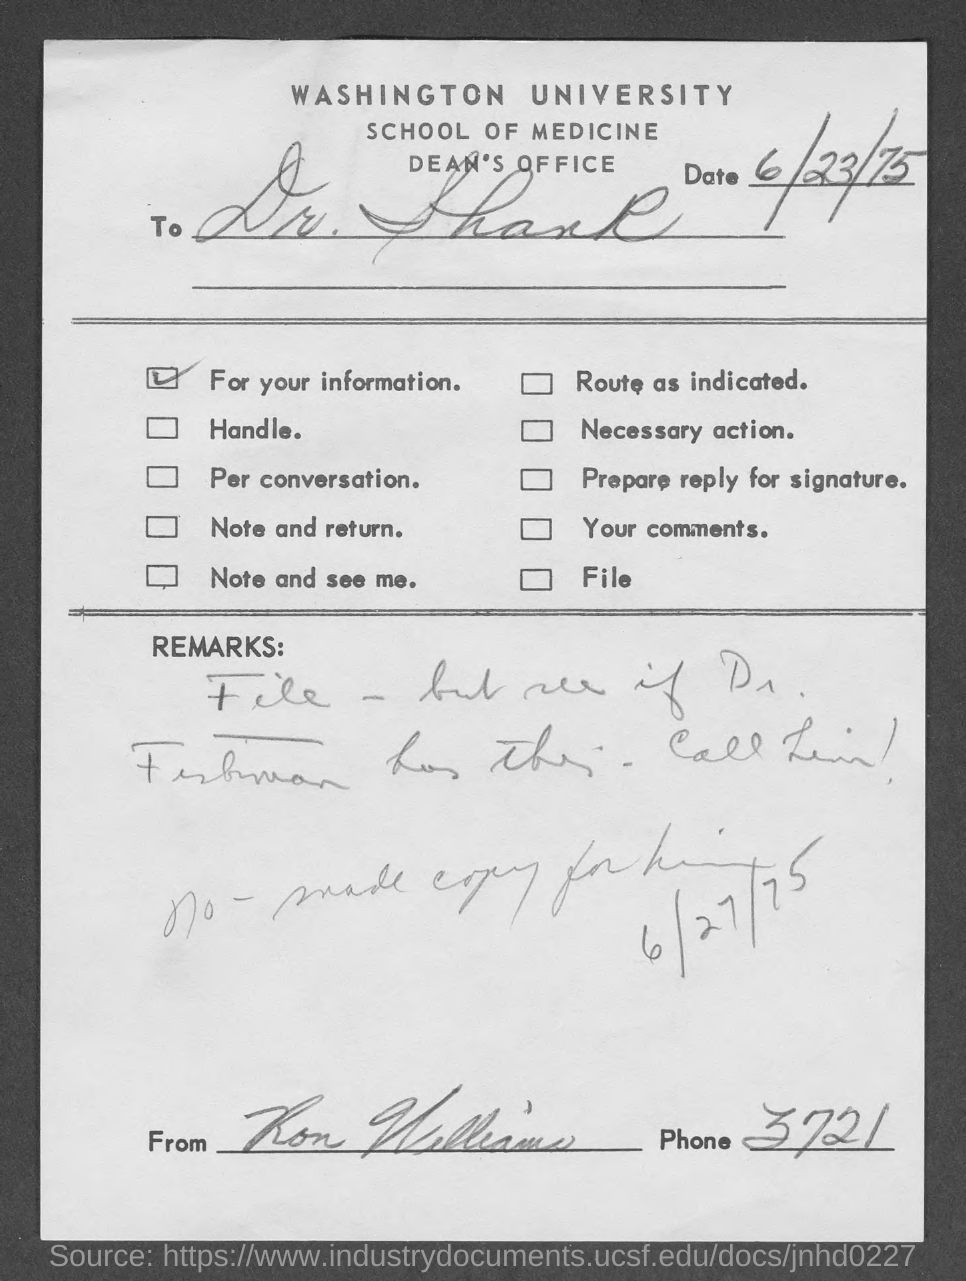Identify some key points in this picture. The document mentions Washington University in the header. The issued date of the document is June 23, 1975. 